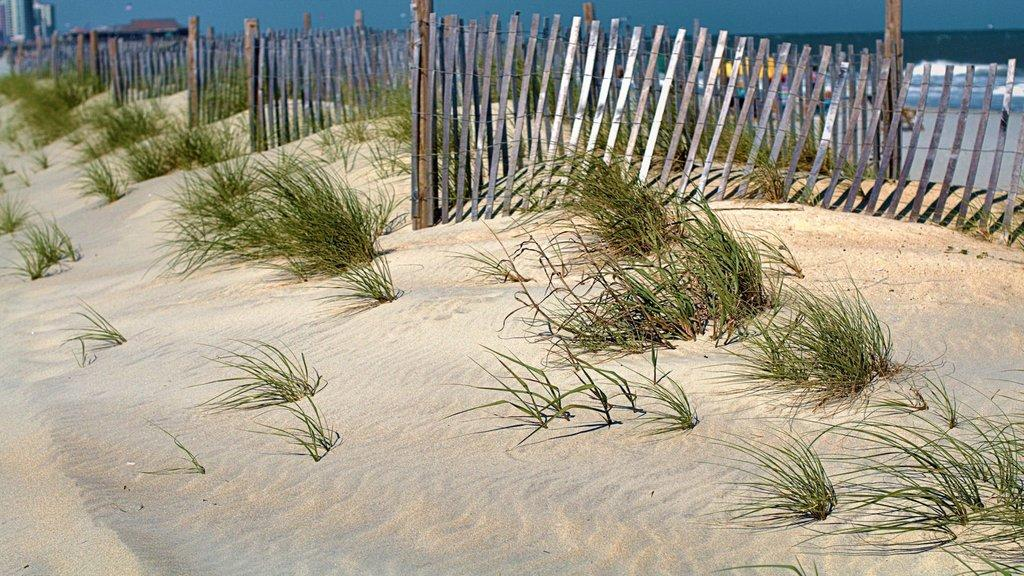What type of barrier can be seen on the land in the image? There is a fence on the land in the image. What is the natural vegetation on the land? The land has grass. What can be seen on the right side of the image? There is water with tides on the right side of the image. What is visible at the top of the image? The sky is visible at the top of the image. What structures can be seen on the left top of the image? There are buildings on the left top of the image. Where is the father standing in the image? There is no father present in the image. How many beans are visible in the image? There are no beans present in the image. 